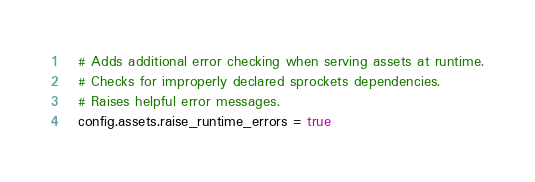Convert code to text. <code><loc_0><loc_0><loc_500><loc_500><_Ruby_>  # Adds additional error checking when serving assets at runtime.
  # Checks for improperly declared sprockets dependencies.
  # Raises helpful error messages.
  config.assets.raise_runtime_errors = true</code> 